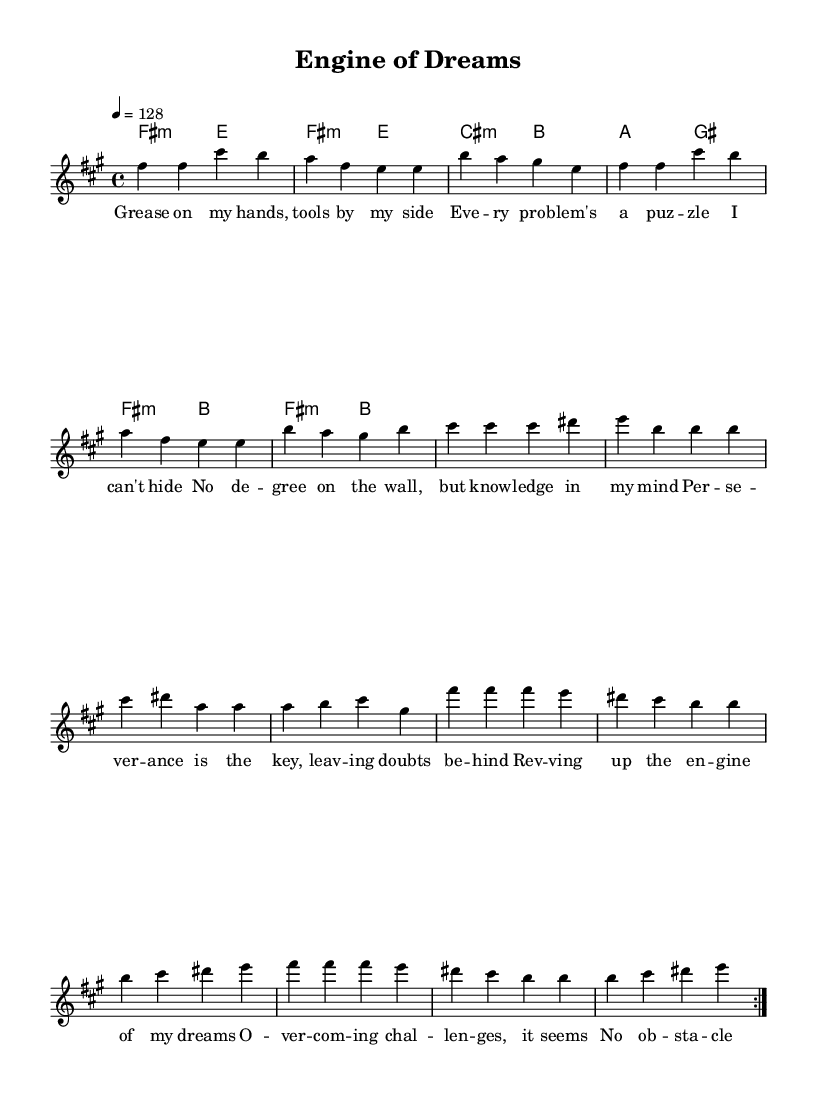What is the key signature of this music? The key signature is F sharp minor, which includes three sharps: F sharp, C sharp, and G sharp. This can be determined by looking at the key signature indicated at the beginning of the staff.
Answer: F sharp minor What is the time signature of this music? The time signature is 4/4, which means there are four beats in each measure and the quarter note gets one beat. This is indicated at the beginning of the score next to the key signature.
Answer: 4/4 What is the tempo of this piece? The tempo is 128 beats per minute, as specified in the tempo marking written above the staff. This indicates the speed at which the piece should be played.
Answer: 128 How many measures are there in the verse section? The verse section contains 6 measures, which can be confirmed by counting the measures in the melody part designated as "Verse."
Answer: 6 Which chord is used in the pre-chorus lyrics? The chords in the pre-chorus include C sharp minor, B, and A. These chords support the melody during the pre-chorus section.
Answer: C sharp minor What theme is being expressed in the lyrics? The lyrics express themes of perseverance and overcoming challenges, as indicated by phrases such as “no obstacle too great” and “I'll never give up.” This reflects the motivational spirit characteristic of high-energy K-Pop tracks.
Answer: Perseverance 